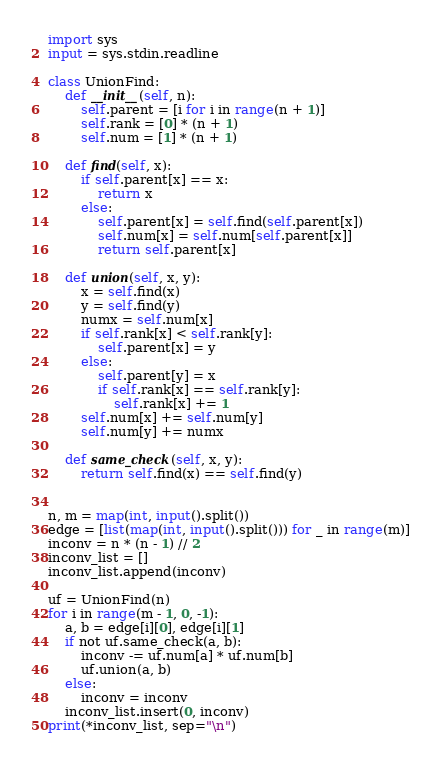Convert code to text. <code><loc_0><loc_0><loc_500><loc_500><_Python_>import sys
input = sys.stdin.readline

class UnionFind:
    def __init__(self, n):
        self.parent = [i for i in range(n + 1)]
        self.rank = [0] * (n + 1)
        self.num = [1] * (n + 1)

    def find(self, x):
        if self.parent[x] == x:
            return x
        else:
            self.parent[x] = self.find(self.parent[x])
            self.num[x] = self.num[self.parent[x]]
            return self.parent[x]

    def union(self, x, y):
        x = self.find(x)
        y = self.find(y)
        numx = self.num[x]
        if self.rank[x] < self.rank[y]:
            self.parent[x] = y
        else:
            self.parent[y] = x
            if self.rank[x] == self.rank[y]:
                self.rank[x] += 1
        self.num[x] += self.num[y]
        self.num[y] += numx

    def same_check(self, x, y):
        return self.find(x) == self.find(y)


n, m = map(int, input().split())
edge = [list(map(int, input().split())) for _ in range(m)]
inconv = n * (n - 1) // 2
inconv_list = []
inconv_list.append(inconv)

uf = UnionFind(n)
for i in range(m - 1, 0, -1):
    a, b = edge[i][0], edge[i][1]
    if not uf.same_check(a, b):
        inconv -= uf.num[a] * uf.num[b]
        uf.union(a, b)
    else:
        inconv = inconv
    inconv_list.insert(0, inconv)
print(*inconv_list, sep="\n")
</code> 